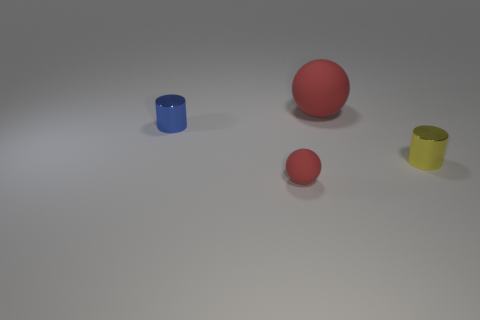Add 1 small balls. How many objects exist? 5 Subtract 0 red cylinders. How many objects are left? 4 Subtract all cyan cylinders. Subtract all purple spheres. How many cylinders are left? 2 Subtract all tiny red metal objects. Subtract all small red spheres. How many objects are left? 3 Add 2 yellow objects. How many yellow objects are left? 3 Add 2 small balls. How many small balls exist? 3 